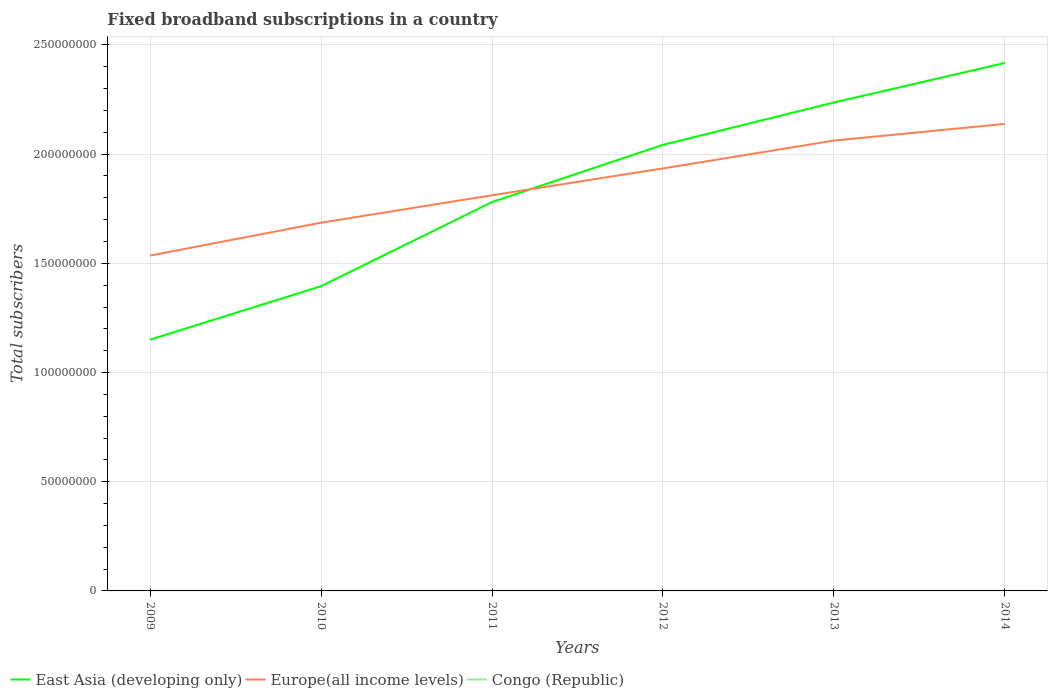Is the number of lines equal to the number of legend labels?
Your response must be concise. Yes. Across all years, what is the maximum number of broadband subscriptions in Congo (Republic)?
Your answer should be compact. 125. In which year was the number of broadband subscriptions in East Asia (developing only) maximum?
Your response must be concise. 2009. What is the total number of broadband subscriptions in Congo (Republic) in the graph?
Provide a succinct answer. 811. What is the difference between the highest and the second highest number of broadband subscriptions in Europe(all income levels)?
Your response must be concise. 6.03e+07. Is the number of broadband subscriptions in Congo (Republic) strictly greater than the number of broadband subscriptions in East Asia (developing only) over the years?
Your answer should be very brief. Yes. How many lines are there?
Offer a very short reply. 3. How many years are there in the graph?
Your response must be concise. 6. What is the difference between two consecutive major ticks on the Y-axis?
Provide a succinct answer. 5.00e+07. Are the values on the major ticks of Y-axis written in scientific E-notation?
Offer a terse response. No. Where does the legend appear in the graph?
Offer a terse response. Bottom left. How many legend labels are there?
Your answer should be compact. 3. What is the title of the graph?
Give a very brief answer. Fixed broadband subscriptions in a country. What is the label or title of the Y-axis?
Offer a very short reply. Total subscribers. What is the Total subscribers in East Asia (developing only) in 2009?
Ensure brevity in your answer.  1.15e+08. What is the Total subscribers of Europe(all income levels) in 2009?
Keep it short and to the point. 1.54e+08. What is the Total subscribers in Congo (Republic) in 2009?
Give a very brief answer. 125. What is the Total subscribers of East Asia (developing only) in 2010?
Offer a very short reply. 1.40e+08. What is the Total subscribers of Europe(all income levels) in 2010?
Provide a short and direct response. 1.69e+08. What is the Total subscribers of Congo (Republic) in 2010?
Keep it short and to the point. 250. What is the Total subscribers of East Asia (developing only) in 2011?
Your answer should be very brief. 1.78e+08. What is the Total subscribers in Europe(all income levels) in 2011?
Offer a very short reply. 1.81e+08. What is the Total subscribers in Congo (Republic) in 2011?
Provide a succinct answer. 1311. What is the Total subscribers of East Asia (developing only) in 2012?
Give a very brief answer. 2.04e+08. What is the Total subscribers in Europe(all income levels) in 2012?
Your answer should be compact. 1.93e+08. What is the Total subscribers of Congo (Republic) in 2012?
Keep it short and to the point. 1392. What is the Total subscribers of East Asia (developing only) in 2013?
Provide a succinct answer. 2.24e+08. What is the Total subscribers of Europe(all income levels) in 2013?
Offer a terse response. 2.06e+08. What is the Total subscribers of Congo (Republic) in 2013?
Give a very brief answer. 438. What is the Total subscribers of East Asia (developing only) in 2014?
Provide a short and direct response. 2.42e+08. What is the Total subscribers of Europe(all income levels) in 2014?
Provide a short and direct response. 2.14e+08. What is the Total subscribers of Congo (Republic) in 2014?
Make the answer very short. 500. Across all years, what is the maximum Total subscribers of East Asia (developing only)?
Make the answer very short. 2.42e+08. Across all years, what is the maximum Total subscribers of Europe(all income levels)?
Your answer should be very brief. 2.14e+08. Across all years, what is the maximum Total subscribers of Congo (Republic)?
Provide a short and direct response. 1392. Across all years, what is the minimum Total subscribers of East Asia (developing only)?
Offer a terse response. 1.15e+08. Across all years, what is the minimum Total subscribers of Europe(all income levels)?
Offer a terse response. 1.54e+08. Across all years, what is the minimum Total subscribers in Congo (Republic)?
Ensure brevity in your answer.  125. What is the total Total subscribers of East Asia (developing only) in the graph?
Your answer should be very brief. 1.10e+09. What is the total Total subscribers of Europe(all income levels) in the graph?
Keep it short and to the point. 1.12e+09. What is the total Total subscribers of Congo (Republic) in the graph?
Your answer should be very brief. 4016. What is the difference between the Total subscribers in East Asia (developing only) in 2009 and that in 2010?
Provide a short and direct response. -2.45e+07. What is the difference between the Total subscribers in Europe(all income levels) in 2009 and that in 2010?
Ensure brevity in your answer.  -1.51e+07. What is the difference between the Total subscribers in Congo (Republic) in 2009 and that in 2010?
Make the answer very short. -125. What is the difference between the Total subscribers of East Asia (developing only) in 2009 and that in 2011?
Offer a terse response. -6.30e+07. What is the difference between the Total subscribers in Europe(all income levels) in 2009 and that in 2011?
Provide a short and direct response. -2.76e+07. What is the difference between the Total subscribers in Congo (Republic) in 2009 and that in 2011?
Give a very brief answer. -1186. What is the difference between the Total subscribers in East Asia (developing only) in 2009 and that in 2012?
Ensure brevity in your answer.  -8.92e+07. What is the difference between the Total subscribers of Europe(all income levels) in 2009 and that in 2012?
Provide a short and direct response. -3.99e+07. What is the difference between the Total subscribers of Congo (Republic) in 2009 and that in 2012?
Give a very brief answer. -1267. What is the difference between the Total subscribers in East Asia (developing only) in 2009 and that in 2013?
Make the answer very short. -1.09e+08. What is the difference between the Total subscribers in Europe(all income levels) in 2009 and that in 2013?
Your answer should be very brief. -5.26e+07. What is the difference between the Total subscribers of Congo (Republic) in 2009 and that in 2013?
Your answer should be very brief. -313. What is the difference between the Total subscribers in East Asia (developing only) in 2009 and that in 2014?
Ensure brevity in your answer.  -1.27e+08. What is the difference between the Total subscribers of Europe(all income levels) in 2009 and that in 2014?
Ensure brevity in your answer.  -6.03e+07. What is the difference between the Total subscribers of Congo (Republic) in 2009 and that in 2014?
Ensure brevity in your answer.  -375. What is the difference between the Total subscribers of East Asia (developing only) in 2010 and that in 2011?
Offer a very short reply. -3.85e+07. What is the difference between the Total subscribers in Europe(all income levels) in 2010 and that in 2011?
Offer a very short reply. -1.26e+07. What is the difference between the Total subscribers of Congo (Republic) in 2010 and that in 2011?
Keep it short and to the point. -1061. What is the difference between the Total subscribers in East Asia (developing only) in 2010 and that in 2012?
Offer a terse response. -6.47e+07. What is the difference between the Total subscribers of Europe(all income levels) in 2010 and that in 2012?
Make the answer very short. -2.48e+07. What is the difference between the Total subscribers of Congo (Republic) in 2010 and that in 2012?
Keep it short and to the point. -1142. What is the difference between the Total subscribers in East Asia (developing only) in 2010 and that in 2013?
Offer a terse response. -8.41e+07. What is the difference between the Total subscribers in Europe(all income levels) in 2010 and that in 2013?
Give a very brief answer. -3.76e+07. What is the difference between the Total subscribers of Congo (Republic) in 2010 and that in 2013?
Ensure brevity in your answer.  -188. What is the difference between the Total subscribers in East Asia (developing only) in 2010 and that in 2014?
Your answer should be very brief. -1.02e+08. What is the difference between the Total subscribers of Europe(all income levels) in 2010 and that in 2014?
Give a very brief answer. -4.52e+07. What is the difference between the Total subscribers of Congo (Republic) in 2010 and that in 2014?
Your answer should be very brief. -250. What is the difference between the Total subscribers in East Asia (developing only) in 2011 and that in 2012?
Your answer should be very brief. -2.62e+07. What is the difference between the Total subscribers of Europe(all income levels) in 2011 and that in 2012?
Your response must be concise. -1.23e+07. What is the difference between the Total subscribers in Congo (Republic) in 2011 and that in 2012?
Keep it short and to the point. -81. What is the difference between the Total subscribers of East Asia (developing only) in 2011 and that in 2013?
Your answer should be very brief. -4.56e+07. What is the difference between the Total subscribers in Europe(all income levels) in 2011 and that in 2013?
Offer a terse response. -2.50e+07. What is the difference between the Total subscribers in Congo (Republic) in 2011 and that in 2013?
Provide a succinct answer. 873. What is the difference between the Total subscribers of East Asia (developing only) in 2011 and that in 2014?
Offer a terse response. -6.37e+07. What is the difference between the Total subscribers in Europe(all income levels) in 2011 and that in 2014?
Make the answer very short. -3.27e+07. What is the difference between the Total subscribers in Congo (Republic) in 2011 and that in 2014?
Keep it short and to the point. 811. What is the difference between the Total subscribers of East Asia (developing only) in 2012 and that in 2013?
Keep it short and to the point. -1.94e+07. What is the difference between the Total subscribers of Europe(all income levels) in 2012 and that in 2013?
Your response must be concise. -1.28e+07. What is the difference between the Total subscribers in Congo (Republic) in 2012 and that in 2013?
Offer a terse response. 954. What is the difference between the Total subscribers in East Asia (developing only) in 2012 and that in 2014?
Your answer should be compact. -3.75e+07. What is the difference between the Total subscribers in Europe(all income levels) in 2012 and that in 2014?
Offer a terse response. -2.04e+07. What is the difference between the Total subscribers of Congo (Republic) in 2012 and that in 2014?
Provide a succinct answer. 892. What is the difference between the Total subscribers of East Asia (developing only) in 2013 and that in 2014?
Offer a terse response. -1.81e+07. What is the difference between the Total subscribers in Europe(all income levels) in 2013 and that in 2014?
Provide a succinct answer. -7.64e+06. What is the difference between the Total subscribers in Congo (Republic) in 2013 and that in 2014?
Make the answer very short. -62. What is the difference between the Total subscribers of East Asia (developing only) in 2009 and the Total subscribers of Europe(all income levels) in 2010?
Ensure brevity in your answer.  -5.35e+07. What is the difference between the Total subscribers of East Asia (developing only) in 2009 and the Total subscribers of Congo (Republic) in 2010?
Make the answer very short. 1.15e+08. What is the difference between the Total subscribers of Europe(all income levels) in 2009 and the Total subscribers of Congo (Republic) in 2010?
Give a very brief answer. 1.54e+08. What is the difference between the Total subscribers in East Asia (developing only) in 2009 and the Total subscribers in Europe(all income levels) in 2011?
Provide a succinct answer. -6.61e+07. What is the difference between the Total subscribers in East Asia (developing only) in 2009 and the Total subscribers in Congo (Republic) in 2011?
Your answer should be compact. 1.15e+08. What is the difference between the Total subscribers in Europe(all income levels) in 2009 and the Total subscribers in Congo (Republic) in 2011?
Provide a succinct answer. 1.54e+08. What is the difference between the Total subscribers of East Asia (developing only) in 2009 and the Total subscribers of Europe(all income levels) in 2012?
Your answer should be very brief. -7.84e+07. What is the difference between the Total subscribers of East Asia (developing only) in 2009 and the Total subscribers of Congo (Republic) in 2012?
Give a very brief answer. 1.15e+08. What is the difference between the Total subscribers of Europe(all income levels) in 2009 and the Total subscribers of Congo (Republic) in 2012?
Provide a succinct answer. 1.54e+08. What is the difference between the Total subscribers in East Asia (developing only) in 2009 and the Total subscribers in Europe(all income levels) in 2013?
Keep it short and to the point. -9.11e+07. What is the difference between the Total subscribers of East Asia (developing only) in 2009 and the Total subscribers of Congo (Republic) in 2013?
Provide a succinct answer. 1.15e+08. What is the difference between the Total subscribers of Europe(all income levels) in 2009 and the Total subscribers of Congo (Republic) in 2013?
Offer a terse response. 1.54e+08. What is the difference between the Total subscribers of East Asia (developing only) in 2009 and the Total subscribers of Europe(all income levels) in 2014?
Your response must be concise. -9.88e+07. What is the difference between the Total subscribers in East Asia (developing only) in 2009 and the Total subscribers in Congo (Republic) in 2014?
Provide a short and direct response. 1.15e+08. What is the difference between the Total subscribers of Europe(all income levels) in 2009 and the Total subscribers of Congo (Republic) in 2014?
Your response must be concise. 1.54e+08. What is the difference between the Total subscribers of East Asia (developing only) in 2010 and the Total subscribers of Europe(all income levels) in 2011?
Offer a terse response. -4.16e+07. What is the difference between the Total subscribers of East Asia (developing only) in 2010 and the Total subscribers of Congo (Republic) in 2011?
Your answer should be very brief. 1.40e+08. What is the difference between the Total subscribers in Europe(all income levels) in 2010 and the Total subscribers in Congo (Republic) in 2011?
Provide a succinct answer. 1.69e+08. What is the difference between the Total subscribers of East Asia (developing only) in 2010 and the Total subscribers of Europe(all income levels) in 2012?
Offer a terse response. -5.39e+07. What is the difference between the Total subscribers of East Asia (developing only) in 2010 and the Total subscribers of Congo (Republic) in 2012?
Your response must be concise. 1.40e+08. What is the difference between the Total subscribers in Europe(all income levels) in 2010 and the Total subscribers in Congo (Republic) in 2012?
Ensure brevity in your answer.  1.69e+08. What is the difference between the Total subscribers in East Asia (developing only) in 2010 and the Total subscribers in Europe(all income levels) in 2013?
Provide a short and direct response. -6.67e+07. What is the difference between the Total subscribers in East Asia (developing only) in 2010 and the Total subscribers in Congo (Republic) in 2013?
Offer a very short reply. 1.40e+08. What is the difference between the Total subscribers in Europe(all income levels) in 2010 and the Total subscribers in Congo (Republic) in 2013?
Ensure brevity in your answer.  1.69e+08. What is the difference between the Total subscribers in East Asia (developing only) in 2010 and the Total subscribers in Europe(all income levels) in 2014?
Your answer should be compact. -7.43e+07. What is the difference between the Total subscribers of East Asia (developing only) in 2010 and the Total subscribers of Congo (Republic) in 2014?
Offer a very short reply. 1.40e+08. What is the difference between the Total subscribers of Europe(all income levels) in 2010 and the Total subscribers of Congo (Republic) in 2014?
Give a very brief answer. 1.69e+08. What is the difference between the Total subscribers in East Asia (developing only) in 2011 and the Total subscribers in Europe(all income levels) in 2012?
Make the answer very short. -1.54e+07. What is the difference between the Total subscribers of East Asia (developing only) in 2011 and the Total subscribers of Congo (Republic) in 2012?
Offer a terse response. 1.78e+08. What is the difference between the Total subscribers of Europe(all income levels) in 2011 and the Total subscribers of Congo (Republic) in 2012?
Offer a very short reply. 1.81e+08. What is the difference between the Total subscribers of East Asia (developing only) in 2011 and the Total subscribers of Europe(all income levels) in 2013?
Your answer should be compact. -2.82e+07. What is the difference between the Total subscribers of East Asia (developing only) in 2011 and the Total subscribers of Congo (Republic) in 2013?
Offer a terse response. 1.78e+08. What is the difference between the Total subscribers of Europe(all income levels) in 2011 and the Total subscribers of Congo (Republic) in 2013?
Your answer should be very brief. 1.81e+08. What is the difference between the Total subscribers of East Asia (developing only) in 2011 and the Total subscribers of Europe(all income levels) in 2014?
Provide a short and direct response. -3.58e+07. What is the difference between the Total subscribers in East Asia (developing only) in 2011 and the Total subscribers in Congo (Republic) in 2014?
Make the answer very short. 1.78e+08. What is the difference between the Total subscribers in Europe(all income levels) in 2011 and the Total subscribers in Congo (Republic) in 2014?
Give a very brief answer. 1.81e+08. What is the difference between the Total subscribers of East Asia (developing only) in 2012 and the Total subscribers of Europe(all income levels) in 2013?
Offer a terse response. -1.96e+06. What is the difference between the Total subscribers in East Asia (developing only) in 2012 and the Total subscribers in Congo (Republic) in 2013?
Make the answer very short. 2.04e+08. What is the difference between the Total subscribers in Europe(all income levels) in 2012 and the Total subscribers in Congo (Republic) in 2013?
Offer a terse response. 1.93e+08. What is the difference between the Total subscribers of East Asia (developing only) in 2012 and the Total subscribers of Europe(all income levels) in 2014?
Keep it short and to the point. -9.60e+06. What is the difference between the Total subscribers of East Asia (developing only) in 2012 and the Total subscribers of Congo (Republic) in 2014?
Your answer should be compact. 2.04e+08. What is the difference between the Total subscribers in Europe(all income levels) in 2012 and the Total subscribers in Congo (Republic) in 2014?
Your response must be concise. 1.93e+08. What is the difference between the Total subscribers of East Asia (developing only) in 2013 and the Total subscribers of Europe(all income levels) in 2014?
Your answer should be compact. 9.78e+06. What is the difference between the Total subscribers in East Asia (developing only) in 2013 and the Total subscribers in Congo (Republic) in 2014?
Keep it short and to the point. 2.24e+08. What is the difference between the Total subscribers in Europe(all income levels) in 2013 and the Total subscribers in Congo (Republic) in 2014?
Provide a short and direct response. 2.06e+08. What is the average Total subscribers of East Asia (developing only) per year?
Your answer should be compact. 1.84e+08. What is the average Total subscribers in Europe(all income levels) per year?
Make the answer very short. 1.86e+08. What is the average Total subscribers in Congo (Republic) per year?
Keep it short and to the point. 669.33. In the year 2009, what is the difference between the Total subscribers of East Asia (developing only) and Total subscribers of Europe(all income levels)?
Ensure brevity in your answer.  -3.85e+07. In the year 2009, what is the difference between the Total subscribers of East Asia (developing only) and Total subscribers of Congo (Republic)?
Provide a succinct answer. 1.15e+08. In the year 2009, what is the difference between the Total subscribers of Europe(all income levels) and Total subscribers of Congo (Republic)?
Provide a succinct answer. 1.54e+08. In the year 2010, what is the difference between the Total subscribers of East Asia (developing only) and Total subscribers of Europe(all income levels)?
Make the answer very short. -2.91e+07. In the year 2010, what is the difference between the Total subscribers of East Asia (developing only) and Total subscribers of Congo (Republic)?
Offer a terse response. 1.40e+08. In the year 2010, what is the difference between the Total subscribers in Europe(all income levels) and Total subscribers in Congo (Republic)?
Provide a short and direct response. 1.69e+08. In the year 2011, what is the difference between the Total subscribers in East Asia (developing only) and Total subscribers in Europe(all income levels)?
Provide a succinct answer. -3.11e+06. In the year 2011, what is the difference between the Total subscribers in East Asia (developing only) and Total subscribers in Congo (Republic)?
Your answer should be very brief. 1.78e+08. In the year 2011, what is the difference between the Total subscribers of Europe(all income levels) and Total subscribers of Congo (Republic)?
Give a very brief answer. 1.81e+08. In the year 2012, what is the difference between the Total subscribers of East Asia (developing only) and Total subscribers of Europe(all income levels)?
Provide a short and direct response. 1.08e+07. In the year 2012, what is the difference between the Total subscribers in East Asia (developing only) and Total subscribers in Congo (Republic)?
Make the answer very short. 2.04e+08. In the year 2012, what is the difference between the Total subscribers in Europe(all income levels) and Total subscribers in Congo (Republic)?
Offer a very short reply. 1.93e+08. In the year 2013, what is the difference between the Total subscribers of East Asia (developing only) and Total subscribers of Europe(all income levels)?
Ensure brevity in your answer.  1.74e+07. In the year 2013, what is the difference between the Total subscribers in East Asia (developing only) and Total subscribers in Congo (Republic)?
Provide a short and direct response. 2.24e+08. In the year 2013, what is the difference between the Total subscribers in Europe(all income levels) and Total subscribers in Congo (Republic)?
Keep it short and to the point. 2.06e+08. In the year 2014, what is the difference between the Total subscribers in East Asia (developing only) and Total subscribers in Europe(all income levels)?
Your response must be concise. 2.79e+07. In the year 2014, what is the difference between the Total subscribers in East Asia (developing only) and Total subscribers in Congo (Republic)?
Provide a succinct answer. 2.42e+08. In the year 2014, what is the difference between the Total subscribers of Europe(all income levels) and Total subscribers of Congo (Republic)?
Keep it short and to the point. 2.14e+08. What is the ratio of the Total subscribers of East Asia (developing only) in 2009 to that in 2010?
Offer a very short reply. 0.82. What is the ratio of the Total subscribers in Europe(all income levels) in 2009 to that in 2010?
Provide a short and direct response. 0.91. What is the ratio of the Total subscribers of East Asia (developing only) in 2009 to that in 2011?
Offer a terse response. 0.65. What is the ratio of the Total subscribers of Europe(all income levels) in 2009 to that in 2011?
Make the answer very short. 0.85. What is the ratio of the Total subscribers of Congo (Republic) in 2009 to that in 2011?
Provide a short and direct response. 0.1. What is the ratio of the Total subscribers in East Asia (developing only) in 2009 to that in 2012?
Give a very brief answer. 0.56. What is the ratio of the Total subscribers of Europe(all income levels) in 2009 to that in 2012?
Your response must be concise. 0.79. What is the ratio of the Total subscribers of Congo (Republic) in 2009 to that in 2012?
Give a very brief answer. 0.09. What is the ratio of the Total subscribers in East Asia (developing only) in 2009 to that in 2013?
Offer a terse response. 0.51. What is the ratio of the Total subscribers in Europe(all income levels) in 2009 to that in 2013?
Ensure brevity in your answer.  0.74. What is the ratio of the Total subscribers of Congo (Republic) in 2009 to that in 2013?
Offer a terse response. 0.29. What is the ratio of the Total subscribers of East Asia (developing only) in 2009 to that in 2014?
Your answer should be compact. 0.48. What is the ratio of the Total subscribers in Europe(all income levels) in 2009 to that in 2014?
Provide a short and direct response. 0.72. What is the ratio of the Total subscribers of East Asia (developing only) in 2010 to that in 2011?
Keep it short and to the point. 0.78. What is the ratio of the Total subscribers of Europe(all income levels) in 2010 to that in 2011?
Provide a succinct answer. 0.93. What is the ratio of the Total subscribers of Congo (Republic) in 2010 to that in 2011?
Your response must be concise. 0.19. What is the ratio of the Total subscribers of East Asia (developing only) in 2010 to that in 2012?
Ensure brevity in your answer.  0.68. What is the ratio of the Total subscribers in Europe(all income levels) in 2010 to that in 2012?
Provide a short and direct response. 0.87. What is the ratio of the Total subscribers in Congo (Republic) in 2010 to that in 2012?
Your answer should be very brief. 0.18. What is the ratio of the Total subscribers in East Asia (developing only) in 2010 to that in 2013?
Offer a terse response. 0.62. What is the ratio of the Total subscribers in Europe(all income levels) in 2010 to that in 2013?
Offer a very short reply. 0.82. What is the ratio of the Total subscribers in Congo (Republic) in 2010 to that in 2013?
Provide a short and direct response. 0.57. What is the ratio of the Total subscribers of East Asia (developing only) in 2010 to that in 2014?
Provide a short and direct response. 0.58. What is the ratio of the Total subscribers of Europe(all income levels) in 2010 to that in 2014?
Offer a very short reply. 0.79. What is the ratio of the Total subscribers of Congo (Republic) in 2010 to that in 2014?
Make the answer very short. 0.5. What is the ratio of the Total subscribers in East Asia (developing only) in 2011 to that in 2012?
Your answer should be very brief. 0.87. What is the ratio of the Total subscribers in Europe(all income levels) in 2011 to that in 2012?
Give a very brief answer. 0.94. What is the ratio of the Total subscribers of Congo (Republic) in 2011 to that in 2012?
Provide a short and direct response. 0.94. What is the ratio of the Total subscribers in East Asia (developing only) in 2011 to that in 2013?
Offer a very short reply. 0.8. What is the ratio of the Total subscribers of Europe(all income levels) in 2011 to that in 2013?
Your answer should be compact. 0.88. What is the ratio of the Total subscribers in Congo (Republic) in 2011 to that in 2013?
Ensure brevity in your answer.  2.99. What is the ratio of the Total subscribers of East Asia (developing only) in 2011 to that in 2014?
Offer a very short reply. 0.74. What is the ratio of the Total subscribers in Europe(all income levels) in 2011 to that in 2014?
Offer a very short reply. 0.85. What is the ratio of the Total subscribers of Congo (Republic) in 2011 to that in 2014?
Your answer should be compact. 2.62. What is the ratio of the Total subscribers of East Asia (developing only) in 2012 to that in 2013?
Your response must be concise. 0.91. What is the ratio of the Total subscribers of Europe(all income levels) in 2012 to that in 2013?
Provide a succinct answer. 0.94. What is the ratio of the Total subscribers of Congo (Republic) in 2012 to that in 2013?
Ensure brevity in your answer.  3.18. What is the ratio of the Total subscribers of East Asia (developing only) in 2012 to that in 2014?
Provide a short and direct response. 0.84. What is the ratio of the Total subscribers in Europe(all income levels) in 2012 to that in 2014?
Give a very brief answer. 0.9. What is the ratio of the Total subscribers in Congo (Republic) in 2012 to that in 2014?
Your answer should be very brief. 2.78. What is the ratio of the Total subscribers of East Asia (developing only) in 2013 to that in 2014?
Your response must be concise. 0.93. What is the ratio of the Total subscribers in Congo (Republic) in 2013 to that in 2014?
Your response must be concise. 0.88. What is the difference between the highest and the second highest Total subscribers of East Asia (developing only)?
Your response must be concise. 1.81e+07. What is the difference between the highest and the second highest Total subscribers in Europe(all income levels)?
Keep it short and to the point. 7.64e+06. What is the difference between the highest and the second highest Total subscribers of Congo (Republic)?
Offer a terse response. 81. What is the difference between the highest and the lowest Total subscribers of East Asia (developing only)?
Keep it short and to the point. 1.27e+08. What is the difference between the highest and the lowest Total subscribers in Europe(all income levels)?
Ensure brevity in your answer.  6.03e+07. What is the difference between the highest and the lowest Total subscribers in Congo (Republic)?
Give a very brief answer. 1267. 